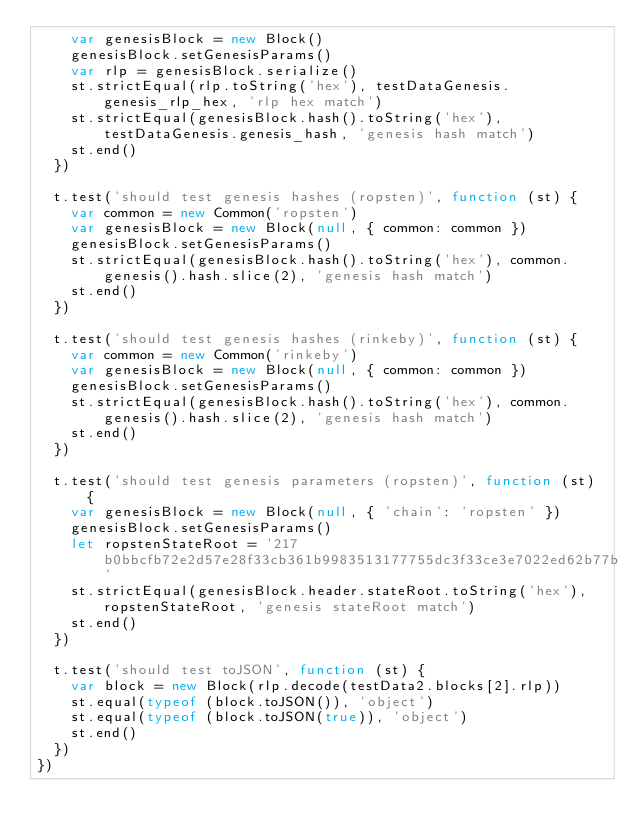<code> <loc_0><loc_0><loc_500><loc_500><_JavaScript_>    var genesisBlock = new Block()
    genesisBlock.setGenesisParams()
    var rlp = genesisBlock.serialize()
    st.strictEqual(rlp.toString('hex'), testDataGenesis.genesis_rlp_hex, 'rlp hex match')
    st.strictEqual(genesisBlock.hash().toString('hex'), testDataGenesis.genesis_hash, 'genesis hash match')
    st.end()
  })

  t.test('should test genesis hashes (ropsten)', function (st) {
    var common = new Common('ropsten')
    var genesisBlock = new Block(null, { common: common })
    genesisBlock.setGenesisParams()
    st.strictEqual(genesisBlock.hash().toString('hex'), common.genesis().hash.slice(2), 'genesis hash match')
    st.end()
  })

  t.test('should test genesis hashes (rinkeby)', function (st) {
    var common = new Common('rinkeby')
    var genesisBlock = new Block(null, { common: common })
    genesisBlock.setGenesisParams()
    st.strictEqual(genesisBlock.hash().toString('hex'), common.genesis().hash.slice(2), 'genesis hash match')
    st.end()
  })

  t.test('should test genesis parameters (ropsten)', function (st) {
    var genesisBlock = new Block(null, { 'chain': 'ropsten' })
    genesisBlock.setGenesisParams()
    let ropstenStateRoot = '217b0bbcfb72e2d57e28f33cb361b9983513177755dc3f33ce3e7022ed62b77b'
    st.strictEqual(genesisBlock.header.stateRoot.toString('hex'), ropstenStateRoot, 'genesis stateRoot match')
    st.end()
  })

  t.test('should test toJSON', function (st) {
    var block = new Block(rlp.decode(testData2.blocks[2].rlp))
    st.equal(typeof (block.toJSON()), 'object')
    st.equal(typeof (block.toJSON(true)), 'object')
    st.end()
  })
})
</code> 